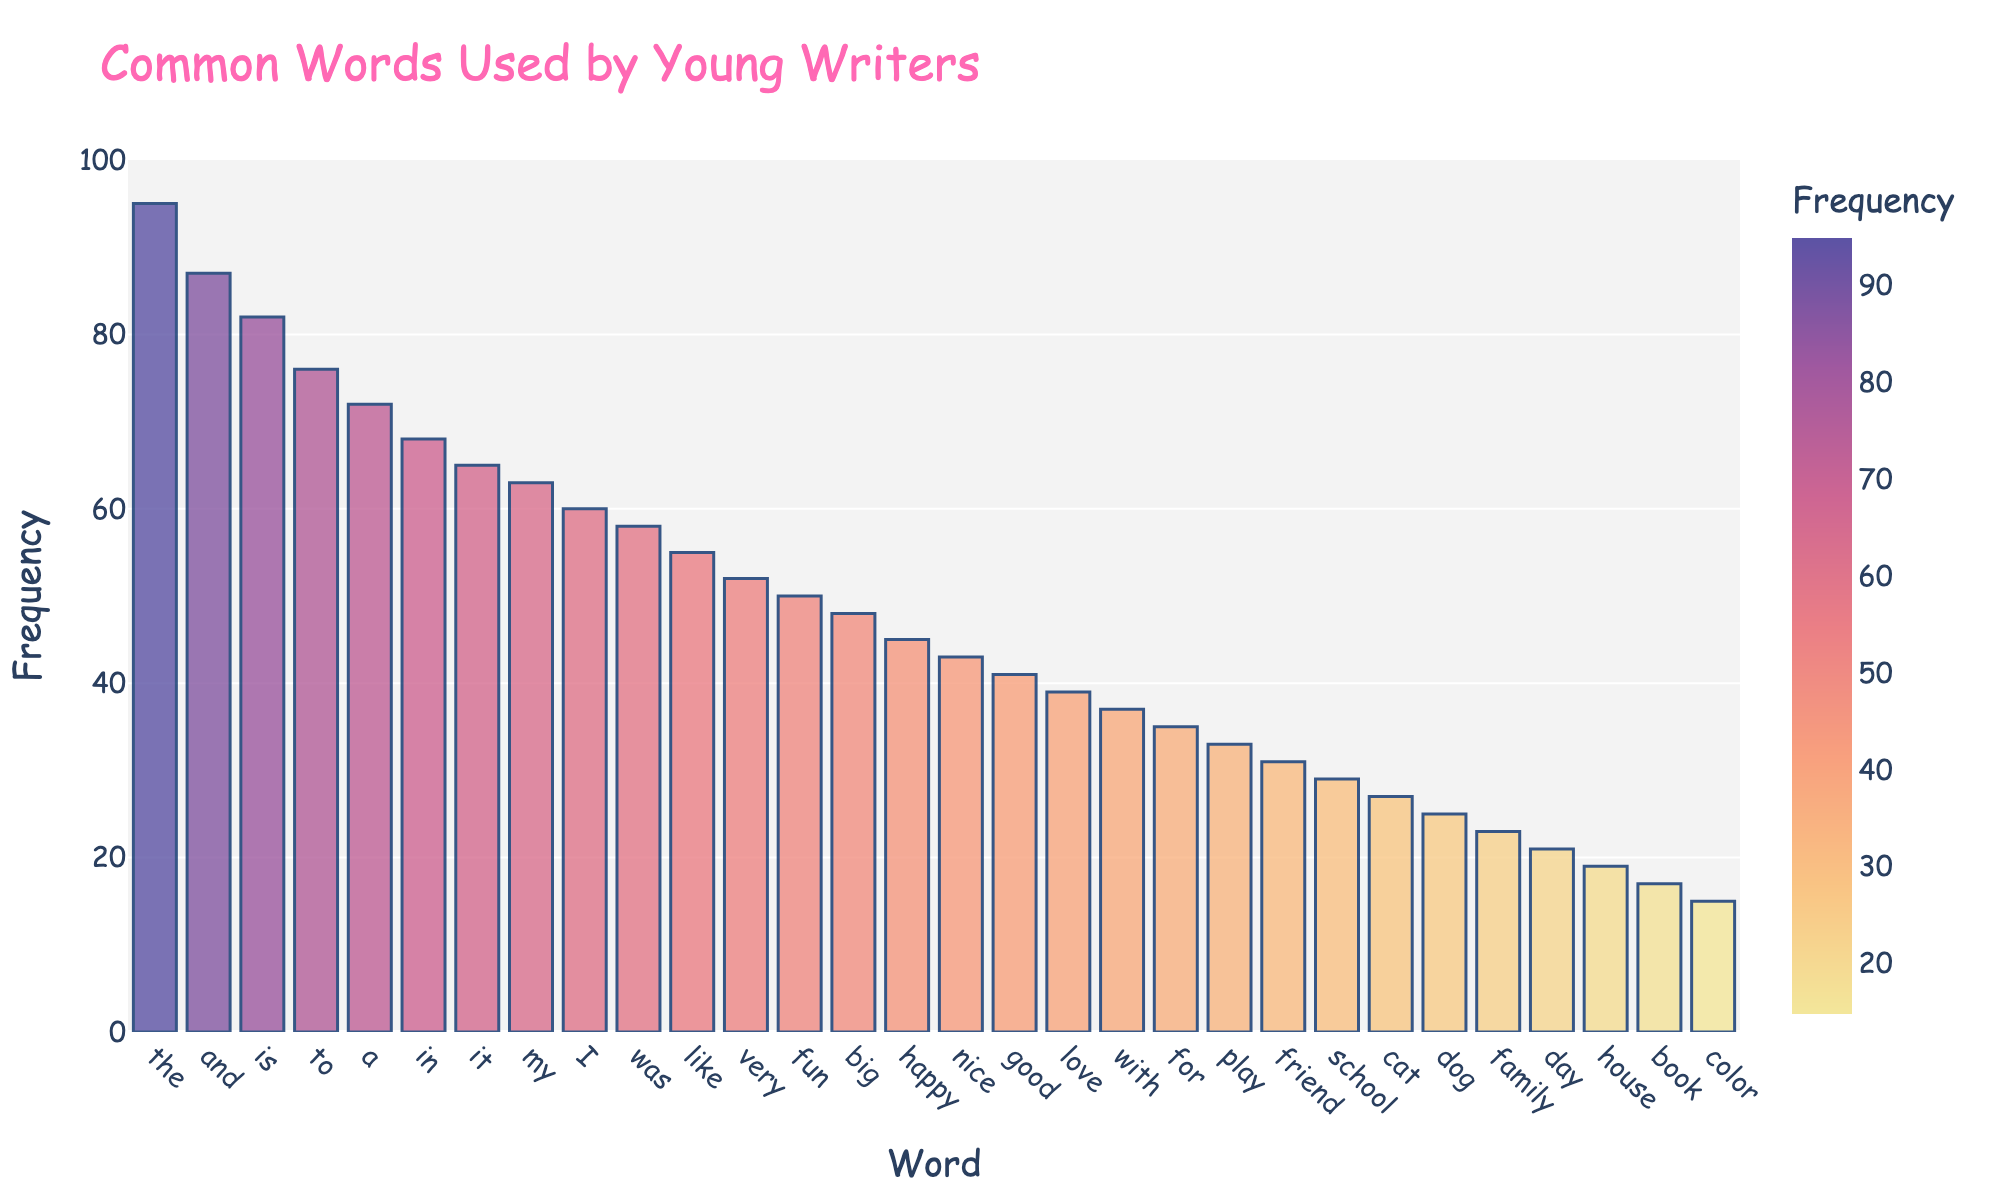what's the most used word in the figure? To find the most used word, we look for the tallest bar in the chart. The word corresponding to the tallest bar is 'the' with a frequency of 95.
Answer: the what's the total frequency of 'cat' and 'dog'? We need to add the frequencies of 'cat' and 'dog'. According to the chart, 'cat' has a frequency of 27 and 'dog' has a frequency of 25. So, 27 + 25 = 52.
Answer: 52 which word has a higher frequency, 'happy' or 'good'? Comparing the heights of the bars, 'happy' has a frequency of 45 and 'good' has a frequency of 41. 'Happy' has a higher frequency.
Answer: happy what's the difference in frequency between 'I' and 'was'? We subtract the frequency of 'was' from 'I'. 'I' has a frequency of 60 and 'was' has a frequency of 58. So, 60 - 58 = 2.
Answer: 2 are there more words with a frequency above 70 or below 70? Count the number of words with frequencies above 70 and those below 70. Words with frequencies above 70 are 'the', 'and', 'is', and 'to'. Words below 70 are the remaining 24 words. Therefore, there are more words with frequencies below 70.
Answer: below 70 what's the color of the bar representing 'love'? Look at the color scale and find the corresponding color for the frequency of 39. According to the chart, it is a shade of orange.
Answer: orange which words have frequencies that are exactly even numbers? Identify words with frequencies that are even (i.e., divisible by 2) from the chart. The even frequencies are: 'the' (95 is odd), 'and' (87 is odd), 'is' (82), 'to' (76), 'a' (72), 'in' (68), 'it' (65 is odd), 'my' (63 is odd), 'I' (60), 'was' (58), 'like' (55 is odd), 'very' (52), 'fun' (50), 'big' (48), 'happy' (45 is odd), 'nice' (43 is odd), 'good' (41 is odd), 'love' (39 is odd), 'with' (37 is odd), 'for' (35 is odd), 'play' (33 is odd), 'friend' (31 is odd), 'school' (29 is odd), 'cat' (27 is odd), 'dog' (25 is odd), 'family' (23 is odd), 'day' (21 is odd), 'house' (19 is odd), 'book' (17 is odd), 'color' (15 is odd). Hence the even frequencies and their corresponding words are: 'is', 'to', 'a', 'in', 'I', 'was', 'very', 'fun', 'big'.
Answer: is, to, a, in, I, was, very, fun, big 